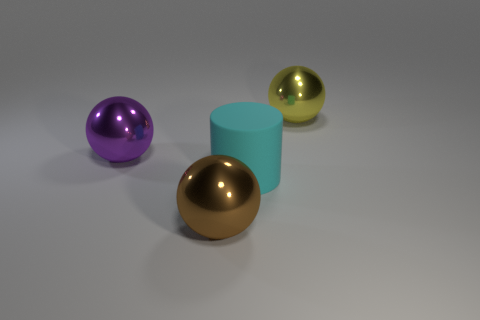What material is the cylinder?
Provide a short and direct response. Rubber. Is the number of big metal things greater than the number of red matte cubes?
Make the answer very short. Yes. Does the big cyan object have the same shape as the big yellow thing?
Keep it short and to the point. No. Are there any other things that are the same shape as the cyan object?
Your answer should be very brief. No. There is a ball on the left side of the brown metallic ball; does it have the same color as the large sphere to the right of the large brown metal thing?
Your response must be concise. No. Are there fewer large cyan cylinders to the left of the large yellow thing than big brown spheres that are on the right side of the cyan thing?
Give a very brief answer. No. What is the shape of the large metal object in front of the cyan thing?
Offer a terse response. Sphere. What number of other objects are there of the same material as the cylinder?
Offer a very short reply. 0. Do the big yellow metallic thing and the metal thing on the left side of the brown metallic thing have the same shape?
Provide a succinct answer. Yes. What is the shape of the yellow thing that is the same material as the purple thing?
Ensure brevity in your answer.  Sphere. 